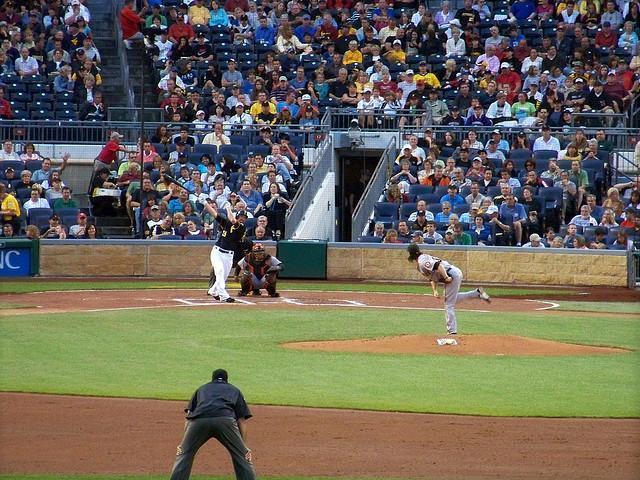How many players are in this shot?
Give a very brief answer. 3. How many people are there?
Give a very brief answer. 4. How many giraffes are looking straight at the camera?
Give a very brief answer. 0. 